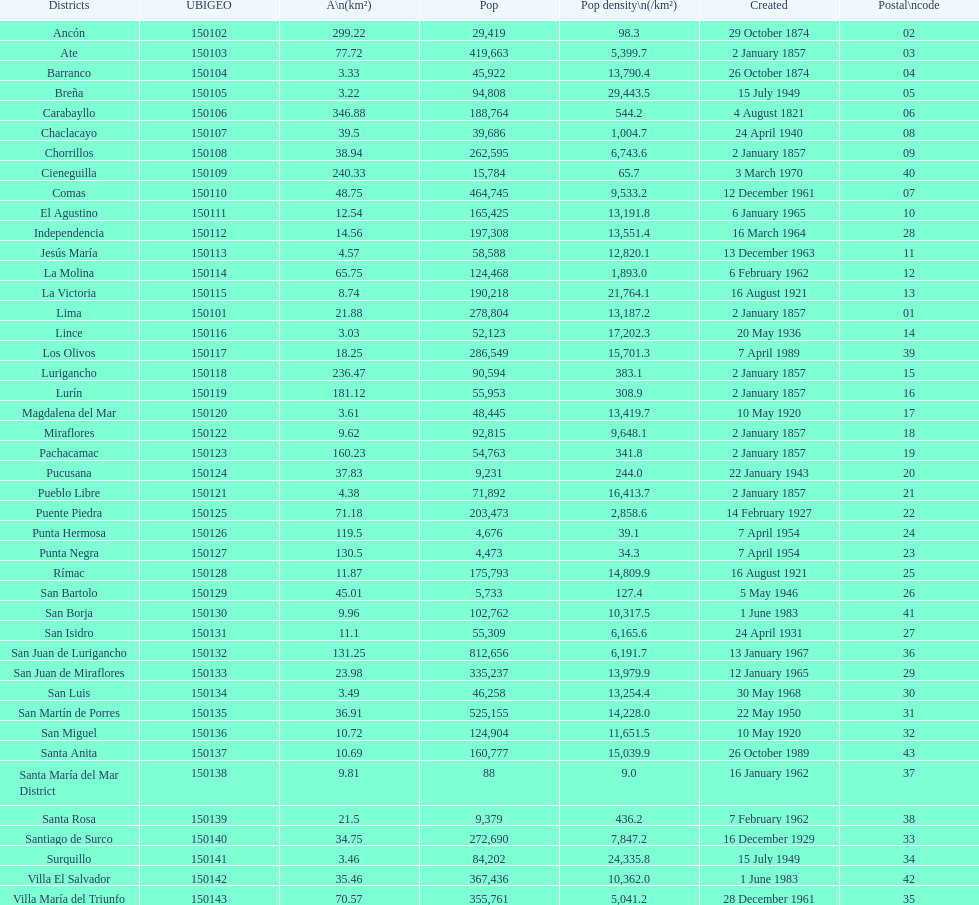How many districts have more than 100,000 people in this city? 21. 